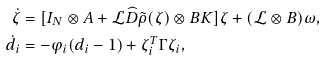<formula> <loc_0><loc_0><loc_500><loc_500>\dot { \zeta } & = [ I _ { N } \otimes A + \mathcal { L } \widehat { D } \tilde { \rho } ( \zeta ) \otimes B K ] \zeta + ( \mathcal { L } \otimes B ) \omega , \\ \dot { d } _ { i } & = - \varphi _ { i } ( d _ { i } - 1 ) + \zeta _ { i } ^ { T } \Gamma \zeta _ { i } ,</formula> 